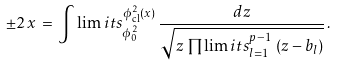<formula> <loc_0><loc_0><loc_500><loc_500>\pm 2 \, x \, = \, \int \lim i t s _ { \phi _ { 0 } ^ { 2 } } ^ { \phi _ { \text {cl} } ^ { 2 } ( x ) } \, \frac { d z } { \sqrt { \, z \, \prod \lim i t s _ { l = 1 } ^ { p - 1 } \, \left ( z - b _ { l } \right ) } } \, .</formula> 